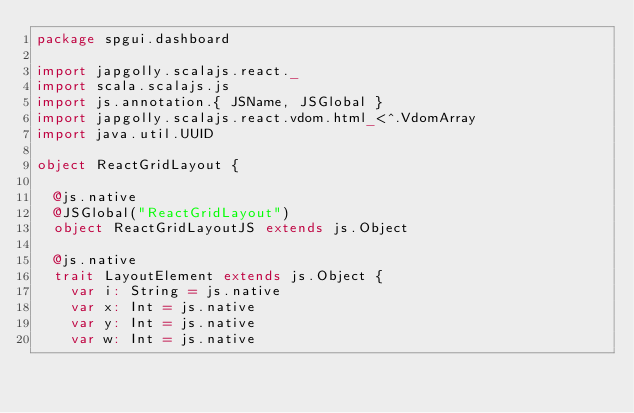<code> <loc_0><loc_0><loc_500><loc_500><_Scala_>package spgui.dashboard

import japgolly.scalajs.react._
import scala.scalajs.js
import js.annotation.{ JSName, JSGlobal }
import japgolly.scalajs.react.vdom.html_<^.VdomArray
import java.util.UUID

object ReactGridLayout {

  @js.native
  @JSGlobal("ReactGridLayout")
  object ReactGridLayoutJS extends js.Object

  @js.native
  trait LayoutElement extends js.Object {
    var i: String = js.native
    var x: Int = js.native
    var y: Int = js.native
    var w: Int = js.native</code> 